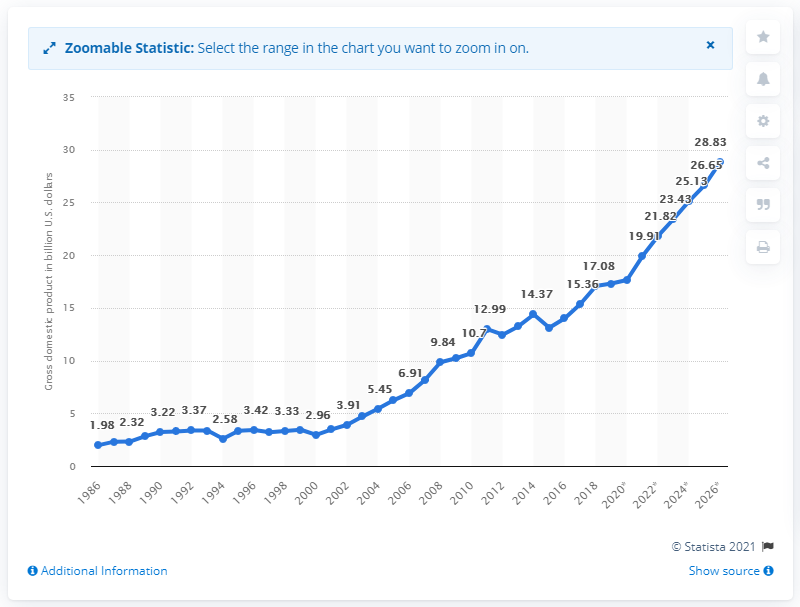Outline some significant characteristics in this image. In 2018, Mali's gross domestic product was valued at 17.08 billion dollars. 